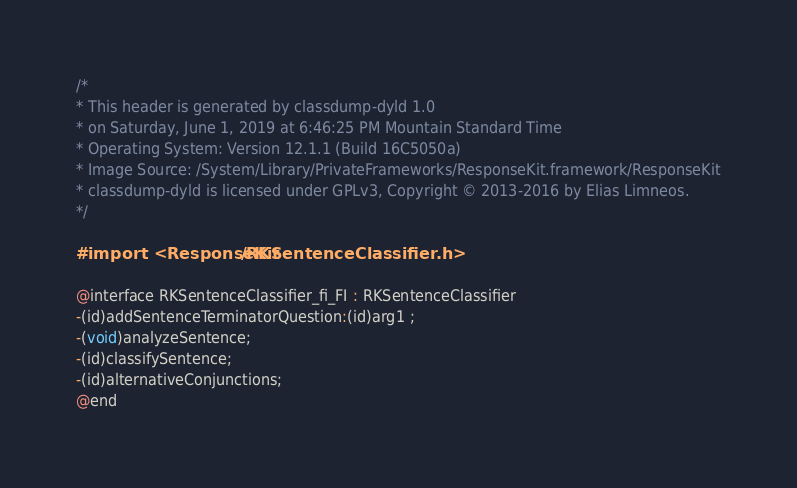Convert code to text. <code><loc_0><loc_0><loc_500><loc_500><_C_>/*
* This header is generated by classdump-dyld 1.0
* on Saturday, June 1, 2019 at 6:46:25 PM Mountain Standard Time
* Operating System: Version 12.1.1 (Build 16C5050a)
* Image Source: /System/Library/PrivateFrameworks/ResponseKit.framework/ResponseKit
* classdump-dyld is licensed under GPLv3, Copyright © 2013-2016 by Elias Limneos.
*/

#import <ResponseKit/RKSentenceClassifier.h>

@interface RKSentenceClassifier_fi_FI : RKSentenceClassifier
-(id)addSentenceTerminatorQuestion:(id)arg1 ;
-(void)analyzeSentence;
-(id)classifySentence;
-(id)alternativeConjunctions;
@end

</code> 